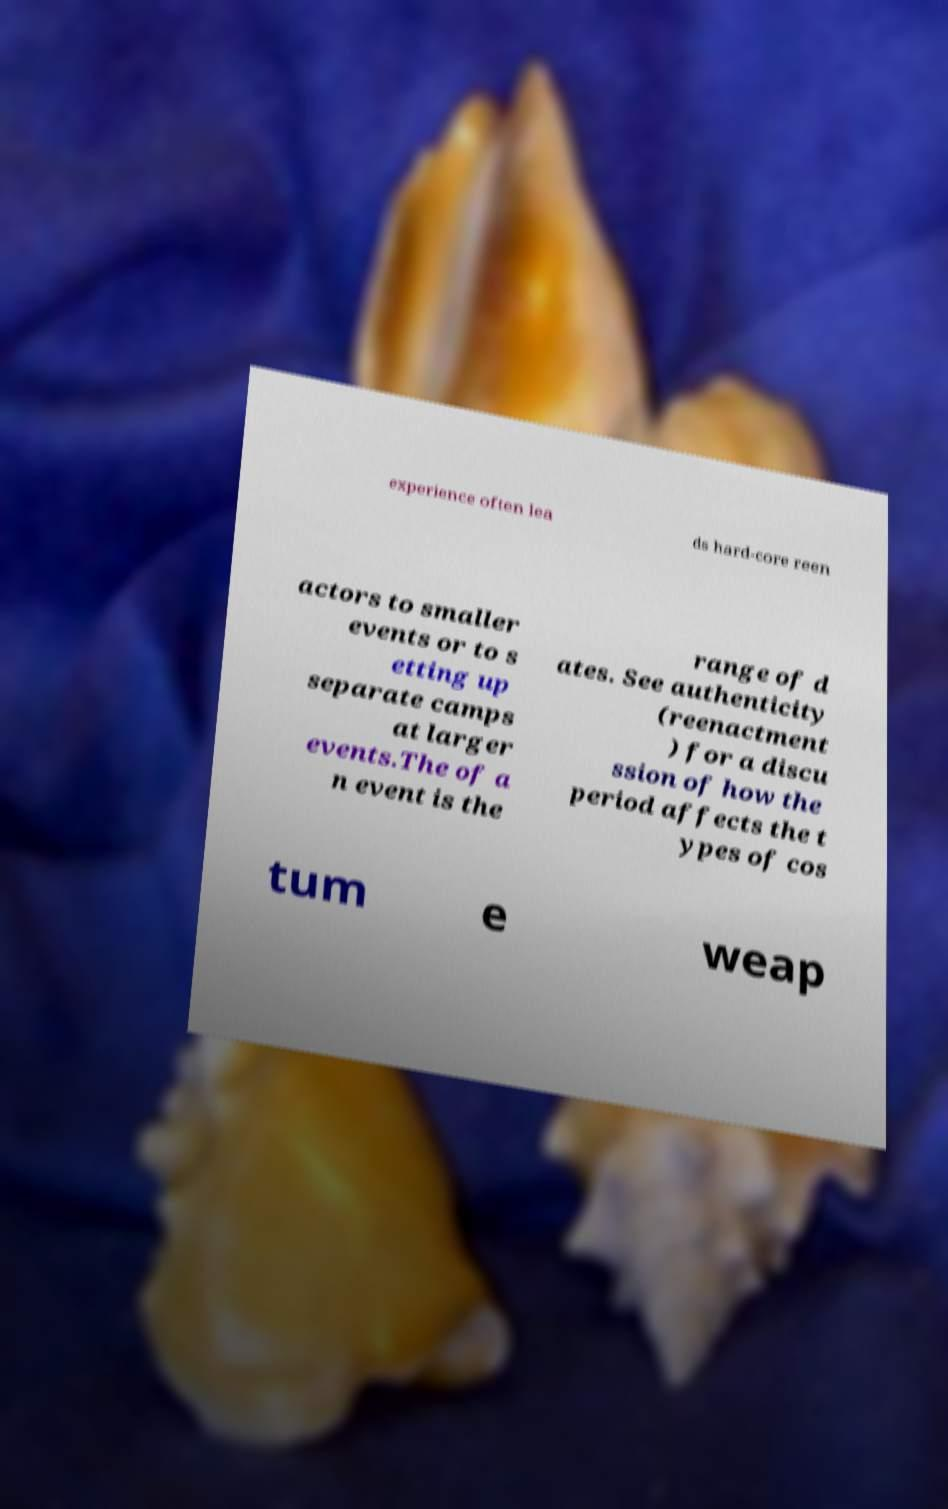For documentation purposes, I need the text within this image transcribed. Could you provide that? experience often lea ds hard-core reen actors to smaller events or to s etting up separate camps at larger events.The of a n event is the range of d ates. See authenticity (reenactment ) for a discu ssion of how the period affects the t ypes of cos tum e weap 